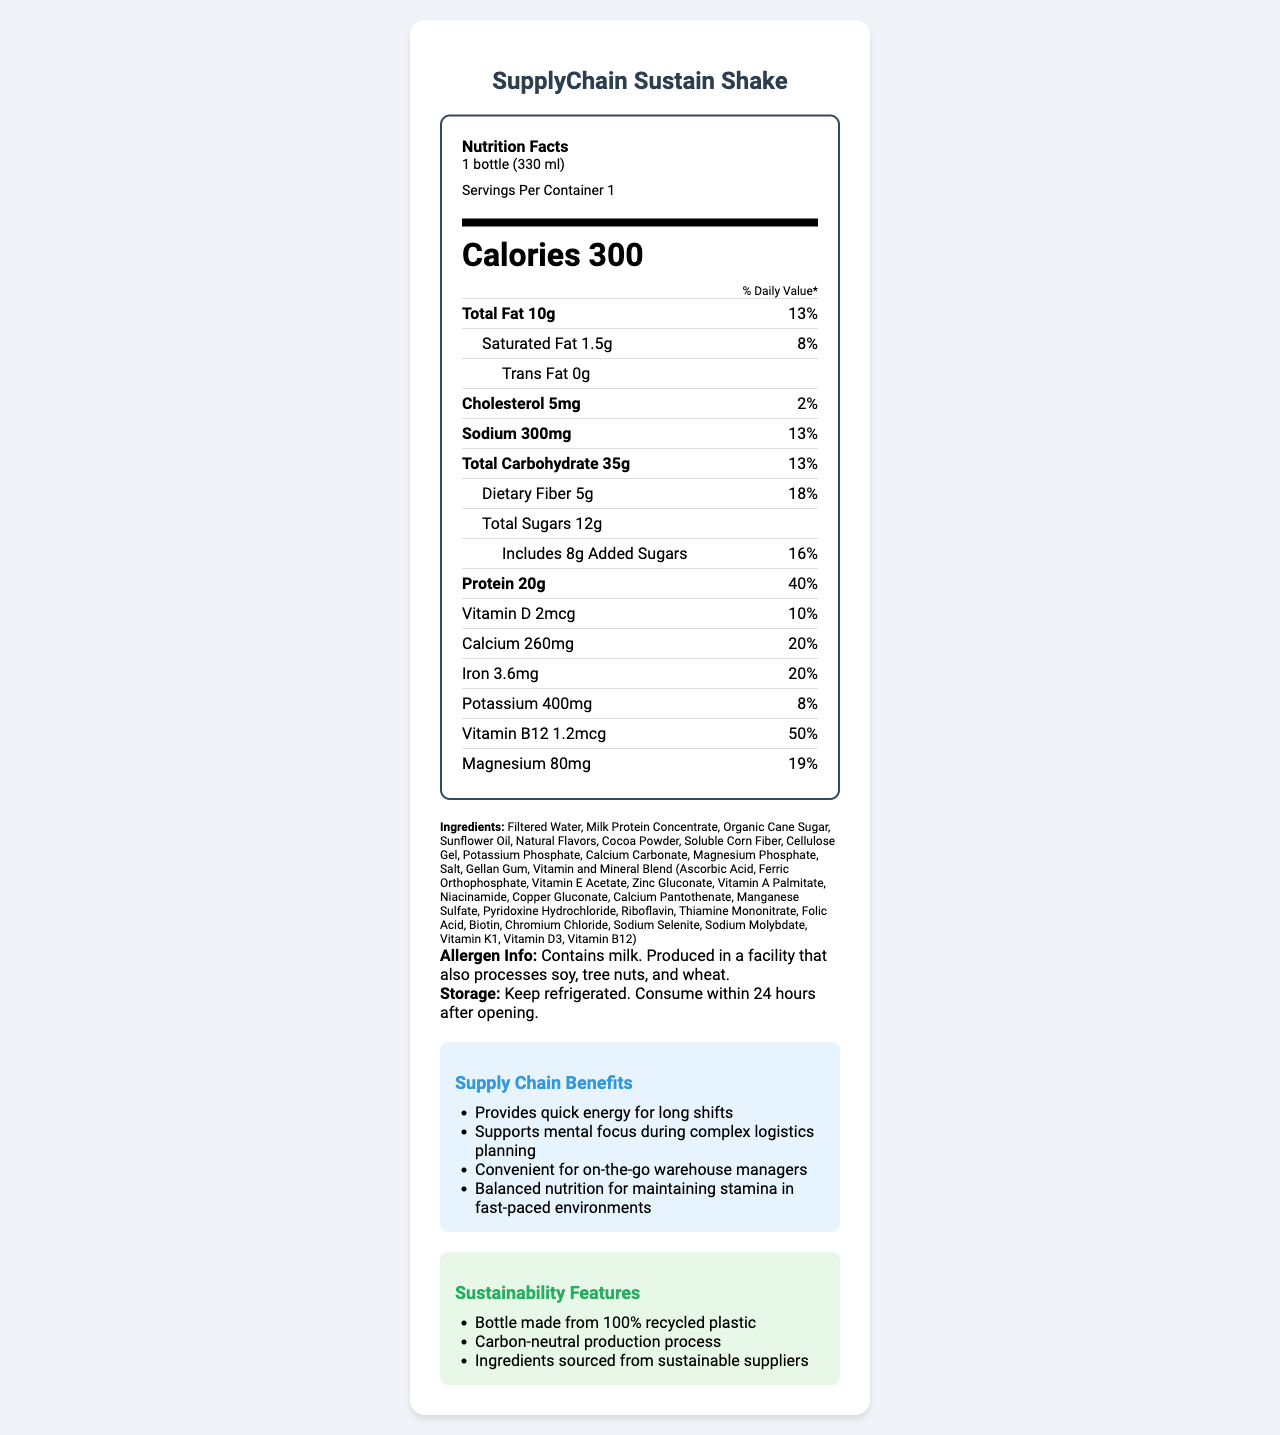what is the serving size of the SupplyChain Sustain Shake? The serving size information is directly stated in the document under the label header, showing "1 bottle (330 ml)".
Answer: 1 bottle (330 ml) how many grams of protein are in each serving? The amount of protein per serving is listed under the nutrients section as "Protein 20g".
Answer: 20g what percentage of the daily value for calcium does this shake provide? The percentage of the daily value for calcium is explicitly stated in the nutrient section as "Calcium 20%".
Answer: 20% what ingredients are listed for the SupplyChain Sustain Shake? The ingredients are listed towards the bottom of the document in the "Ingredients" section.
Answer: Filtered Water, Milk Protein Concentrate, Organic Cane Sugar, Sunflower Oil, Natural Flavors, Cocoa Powder, Soluble Corn Fiber, Cellulose Gel, Potassium Phosphate, Calcium Carbonate, Magnesium Phosphate, Salt, Gellan Gum, Vitamin and Mineral Blend (Ascorbic Acid, Ferric Orthophosphate, Vitamin E Acetate, Zinc Gluconate, Vitamin A Palmitate, Niacinamide, Copper Gluconate, Calcium Pantothenate, Manganese Sulfate, Pyridoxine Hydrochloride, Riboflavin, Thiamine Mononitrate, Folic Acid, Biotin, Chromium Chloride, Sodium Selenite, Sodium Molybdate, Vitamin K1, Vitamin D3, Vitamin B12) does this product contain any allergens? The allergen information is provided: "Contains milk. Produced in a facility that also processes soy, tree nuts, and wheat."
Answer: Yes how much sodium does each serving contain? The amount of sodium per serving is listed as "Sodium 300mg" in the nutrient section.
Answer: 300mg what are the sustainability features mentioned for this product? The sustainability features are listed in a dedicated section in the document.
Answer: Bottle made from 100% recycled plastic, Carbon-neutral production process, Ingredients sourced from sustainable suppliers what is the primary benefit of this shake for supply chain managers? This is one of the specific supply chain benefits listed towards the end of the document.
Answer: Provides quick energy for long shifts Summary question: What information does the SupplyChain Sustain Shake Nutrition Facts Label provide? The document includes detailed labeling on nutritional content, ingredient list, and functional aspects of the product, aimed particularly at supply chain managers. It encompasses calories, fats, carbohydrates, proteins, vitamins, and minerals, with percentages of daily values. The label also includes specific benefits for supply chain managers, such as providing quick energy and supporting mental focus, along with sustainability features like recycled packaging.
Answer: The label provides comprehensive nutritional information for a single serving of the SupplyChain Sustain Shake, including calories, macronutrients, vitamins, and minerals. It also lists ingredients, allergen information, and storage instructions. Additionally, it highlights supply chain benefits and sustainability features of the product. What is the daily value percentage of dietary fiber? The daily value percentage of dietary fiber is specifically mentioned in the document as "Dietary Fiber 18%".
Answer: 18% Which of the following is the correct amount of added sugars per serving? A. 12g B. 10g C. 8g D. 5g The label specifically states "Includes 8g Added Sugars".
Answer: C. 8g True or False: The SupplyChain Sustain Shake is suitable for individuals with soy allergies. The allergen information states that the product is "Produced in a facility that also processes soy", indicating potential cross-contamination.
Answer: False Which of the following vitamins or minerals has the highest percentage daily value in the shake? 1. Vitamin D 2. Iron 3. Vitamin B12 4. Magnesium Vitamin B12 has the highest percentage daily value listed at 50%, whereas others like Vitamin D, Iron, and Magnesium have 10%, 20%, and 19%, respectively.
Answer: 3. Vitamin B12 What is the carbon footprint of producing this shake? The document mentions a carbon-neutral production process but does not disclose specific carbon footprint metrics or data.
Answer: Not enough information How should the SupplyChain Sustain Shake be stored once opened? The storage instructions are clearly specified in the document: "Keep refrigerated. Consume within 24 hours after opening."
Answer: Keep refrigerated. Consume within 24 hours after opening. In what type of facility is this product produced? A. Facility that only processes milk B. Facility that processes soy and tree nuts C. Facility that processes peanuts D. Facility that only processes wheat The allergen info states: "Produced in a facility that also processes soy, tree nuts, and wheat."
Answer: B. Facility that processes soy and tree nuts 